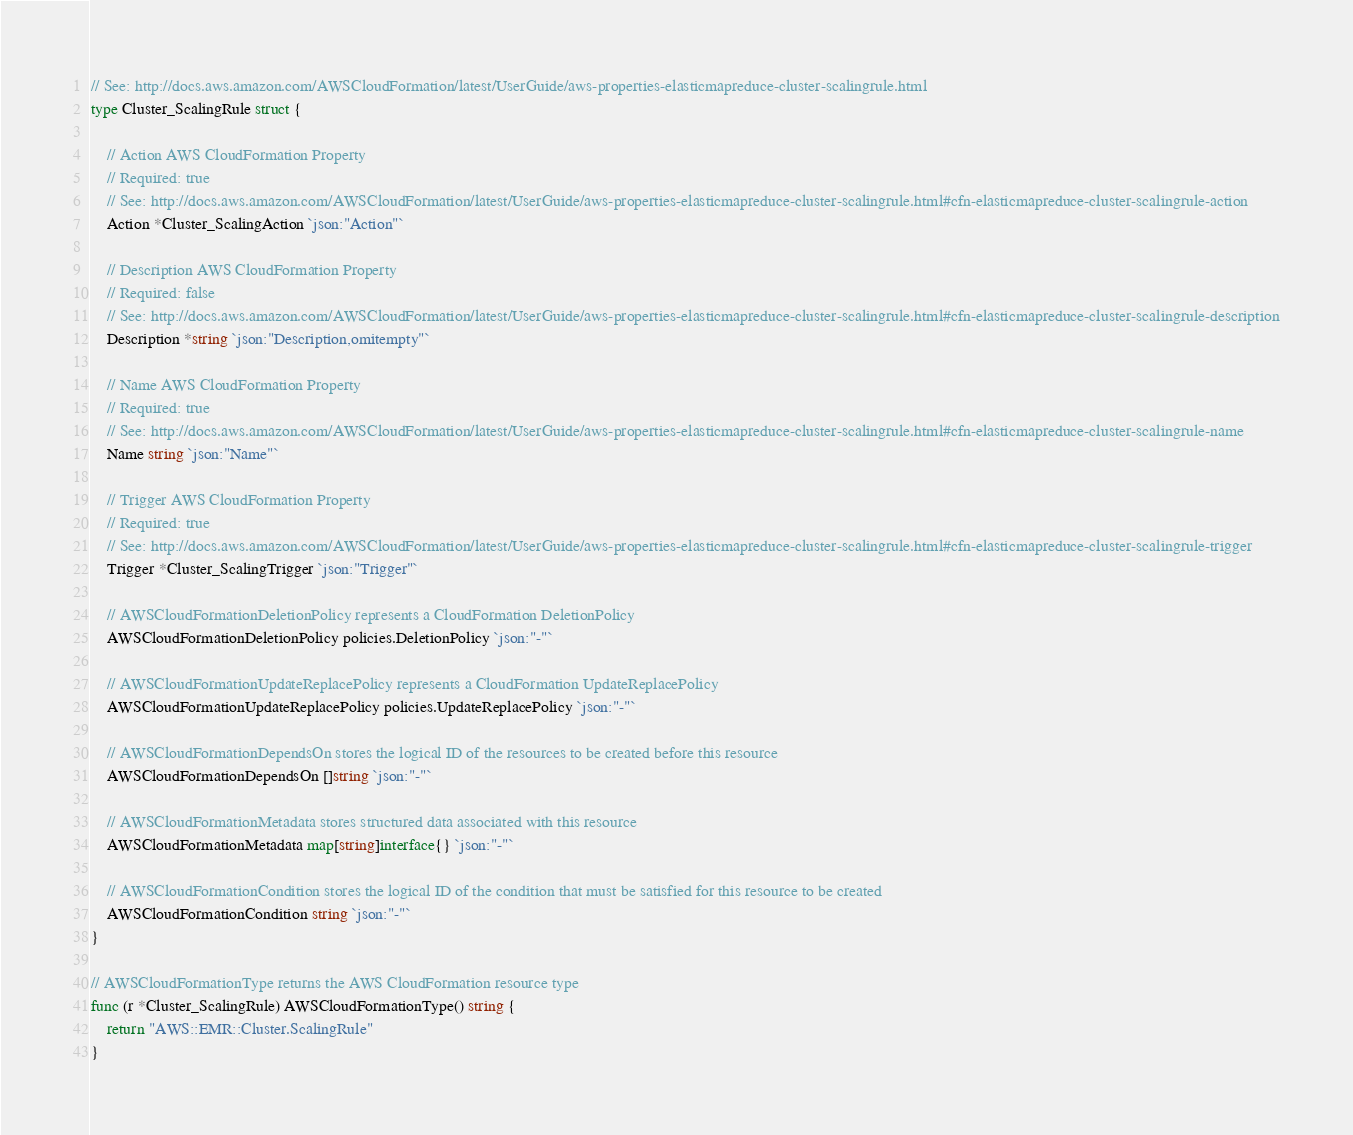<code> <loc_0><loc_0><loc_500><loc_500><_Go_>// See: http://docs.aws.amazon.com/AWSCloudFormation/latest/UserGuide/aws-properties-elasticmapreduce-cluster-scalingrule.html
type Cluster_ScalingRule struct {

	// Action AWS CloudFormation Property
	// Required: true
	// See: http://docs.aws.amazon.com/AWSCloudFormation/latest/UserGuide/aws-properties-elasticmapreduce-cluster-scalingrule.html#cfn-elasticmapreduce-cluster-scalingrule-action
	Action *Cluster_ScalingAction `json:"Action"`

	// Description AWS CloudFormation Property
	// Required: false
	// See: http://docs.aws.amazon.com/AWSCloudFormation/latest/UserGuide/aws-properties-elasticmapreduce-cluster-scalingrule.html#cfn-elasticmapreduce-cluster-scalingrule-description
	Description *string `json:"Description,omitempty"`

	// Name AWS CloudFormation Property
	// Required: true
	// See: http://docs.aws.amazon.com/AWSCloudFormation/latest/UserGuide/aws-properties-elasticmapreduce-cluster-scalingrule.html#cfn-elasticmapreduce-cluster-scalingrule-name
	Name string `json:"Name"`

	// Trigger AWS CloudFormation Property
	// Required: true
	// See: http://docs.aws.amazon.com/AWSCloudFormation/latest/UserGuide/aws-properties-elasticmapreduce-cluster-scalingrule.html#cfn-elasticmapreduce-cluster-scalingrule-trigger
	Trigger *Cluster_ScalingTrigger `json:"Trigger"`

	// AWSCloudFormationDeletionPolicy represents a CloudFormation DeletionPolicy
	AWSCloudFormationDeletionPolicy policies.DeletionPolicy `json:"-"`

	// AWSCloudFormationUpdateReplacePolicy represents a CloudFormation UpdateReplacePolicy
	AWSCloudFormationUpdateReplacePolicy policies.UpdateReplacePolicy `json:"-"`

	// AWSCloudFormationDependsOn stores the logical ID of the resources to be created before this resource
	AWSCloudFormationDependsOn []string `json:"-"`

	// AWSCloudFormationMetadata stores structured data associated with this resource
	AWSCloudFormationMetadata map[string]interface{} `json:"-"`

	// AWSCloudFormationCondition stores the logical ID of the condition that must be satisfied for this resource to be created
	AWSCloudFormationCondition string `json:"-"`
}

// AWSCloudFormationType returns the AWS CloudFormation resource type
func (r *Cluster_ScalingRule) AWSCloudFormationType() string {
	return "AWS::EMR::Cluster.ScalingRule"
}
</code> 